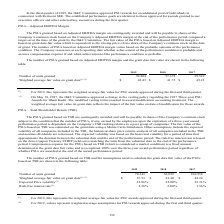According to Sealed Air Corporation's financial document, How was the fair value of the PSUs based on TSR estimated? a Monte Carlo Simulation. The document states: "ased on TSR was estimated on the grant date using a Monte Carlo Simulation. Other assumptions include the expected volatility of all companies include..." Also, What does the table represent? The number of PSUs granted based on TSR and the assumptions used to calculate the grant date fair value of the PSUs based on TSR. The document states: "The number of PSUs granted based on TSR and the assumptions used to calculate the grant date fair value of the PSUs based on TSR are shown in the foll..." Also, On may 18, 2017,  what did the O&C Committee approve? Based on the financial document, the answer is a change in the vesting policy regarding the existing 2017 Three year PSU Awards for Ilham Kadri.. Also, can you calculate: What is the average Risk-free interest rate for the 3 years? To answer this question, I need to perform calculations using the financial data. The calculation is: (2.36+2.00+1.56)/3, which equals 1.97 (percentage). This is based on the information: "22.86% 22.00% 25.31 % Risk-free interest rate (2) 2.36% 2.00% 1.56 % % 25.31 % Risk-free interest rate (2) 2.36% 2.00% 1.56 % 22.00% 25.31 % Risk-free interest rate (2) 2.36% 2.00% 1.56 %..." The key data points involved are: 1.56, 2.00, 2.36. Also, can you calculate: What is the number of units granted for 2019 expressed as a percentage of all units granted? To answer this question, I need to perform calculations using the financial data. The calculation is: 70,543/(70,543+56,829+100,958), which equals 30.9 (percentage). This is based on the information: "9 2018 2017 Number of units granted 70,543 56,829 100,958 2019 2018 2017 Number of units granted 70,543 56,829 100,958 2019 2018 2017 Number of units granted 70,543 56,829 100,958..." The key data points involved are: 100,958, 56,829, 70,543. Also, can you calculate: What is the average Number of units granted for the 3 years? To answer this question, I need to perform calculations using the financial data. The calculation is: (70,543+56,829+100,958)/3, which equals 76110. This is based on the information: "9 2018 2017 Number of units granted 70,543 56,829 100,958 2019 2018 2017 Number of units granted 70,543 56,829 100,958 2019 2018 2017 Number of units granted 70,543 56,829 100,958..." The key data points involved are: 100,958, 56,829, 70,543. 